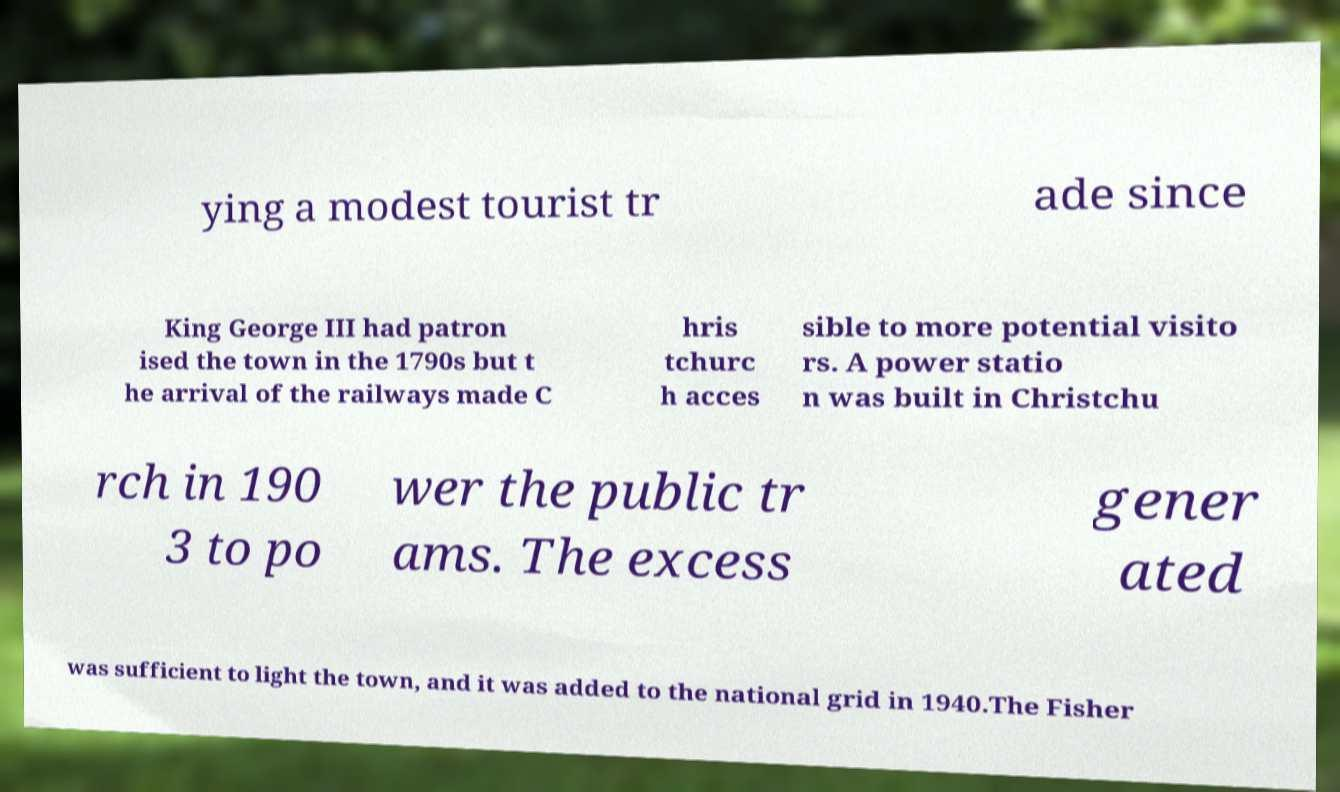Can you accurately transcribe the text from the provided image for me? ying a modest tourist tr ade since King George III had patron ised the town in the 1790s but t he arrival of the railways made C hris tchurc h acces sible to more potential visito rs. A power statio n was built in Christchu rch in 190 3 to po wer the public tr ams. The excess gener ated was sufficient to light the town, and it was added to the national grid in 1940.The Fisher 